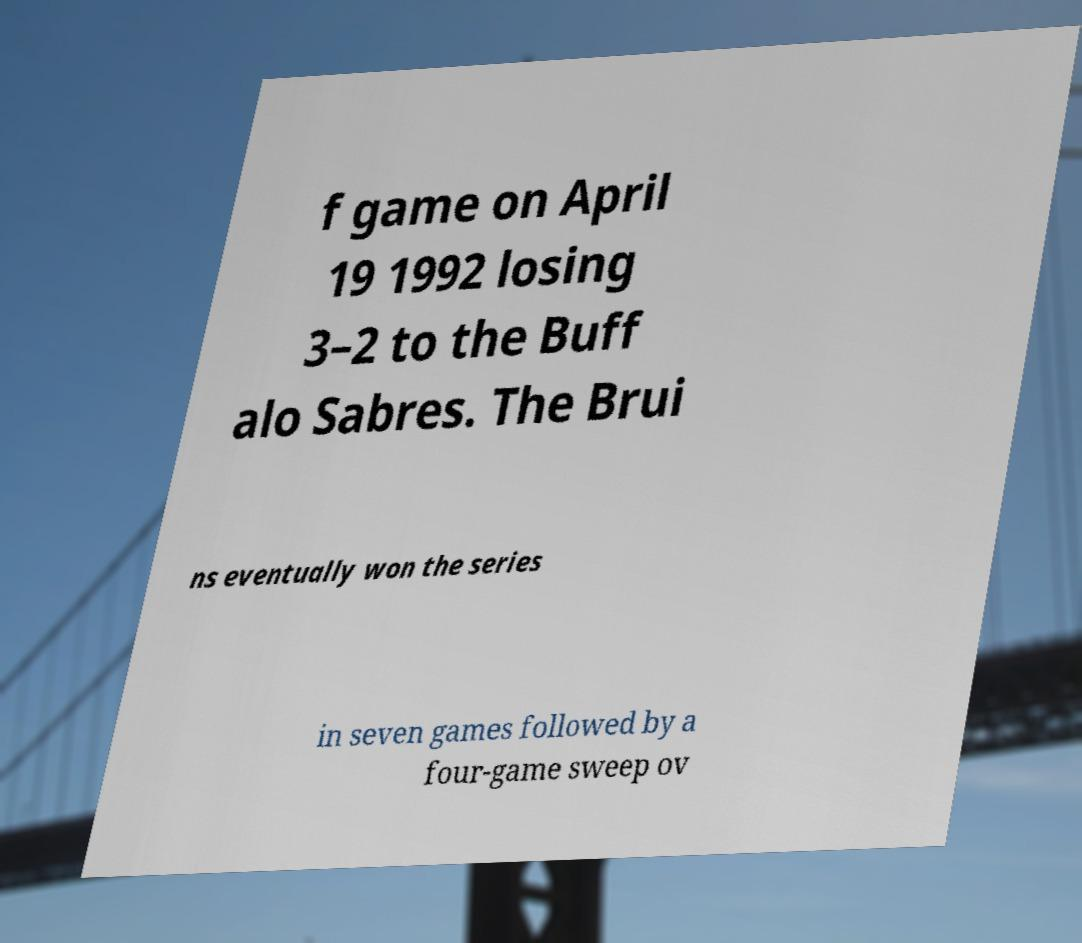I need the written content from this picture converted into text. Can you do that? f game on April 19 1992 losing 3–2 to the Buff alo Sabres. The Brui ns eventually won the series in seven games followed by a four-game sweep ov 